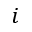<formula> <loc_0><loc_0><loc_500><loc_500>i</formula> 